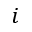<formula> <loc_0><loc_0><loc_500><loc_500>i</formula> 